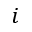<formula> <loc_0><loc_0><loc_500><loc_500>i</formula> 